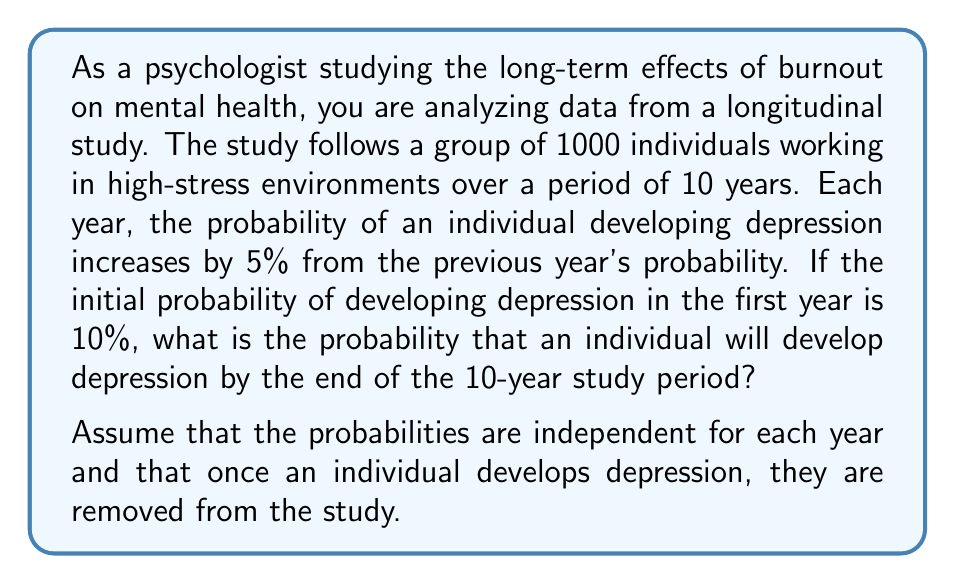Help me with this question. To solve this problem, we need to use the concept of probability of at least one event occurring in a series of independent trials. In this case, we want to find the probability of developing depression at least once over the 10-year period.

Let's approach this step-by-step:

1) First, let's calculate the probability of developing depression for each year:
   Year 1: 10%
   Year 2: 10% + 5% = 15%
   Year 3: 15% + 5% = 20%
   ...and so on.

2) We can represent this as a sequence:
   $p_n = 0.10 + 0.05(n-1)$, where $n$ is the year number (1 to 10)

3) Now, let's calculate the probability of not developing depression for each year:
   Year 1: 1 - 0.10 = 0.90
   Year 2: 1 - 0.15 = 0.85
   Year 3: 1 - 0.20 = 0.80
   ...and so on.

4) The probability of not developing depression over all 10 years is the product of these probabilities:

   $$P(\text{no depression}) = \prod_{n=1}^{10} (1 - (0.10 + 0.05(n-1)))$$

5) Let's calculate this:
   $0.90 \times 0.85 \times 0.80 \times 0.75 \times 0.70 \times 0.65 \times 0.60 \times 0.55 \times 0.50 \times 0.45 \approx 0.0085$

6) Therefore, the probability of developing depression at least once over the 10 years is:

   $$P(\text{depression}) = 1 - P(\text{no depression}) = 1 - 0.0085 = 0.9915$$
Answer: The probability that an individual will develop depression by the end of the 10-year study period is approximately 0.9915 or 99.15%. 